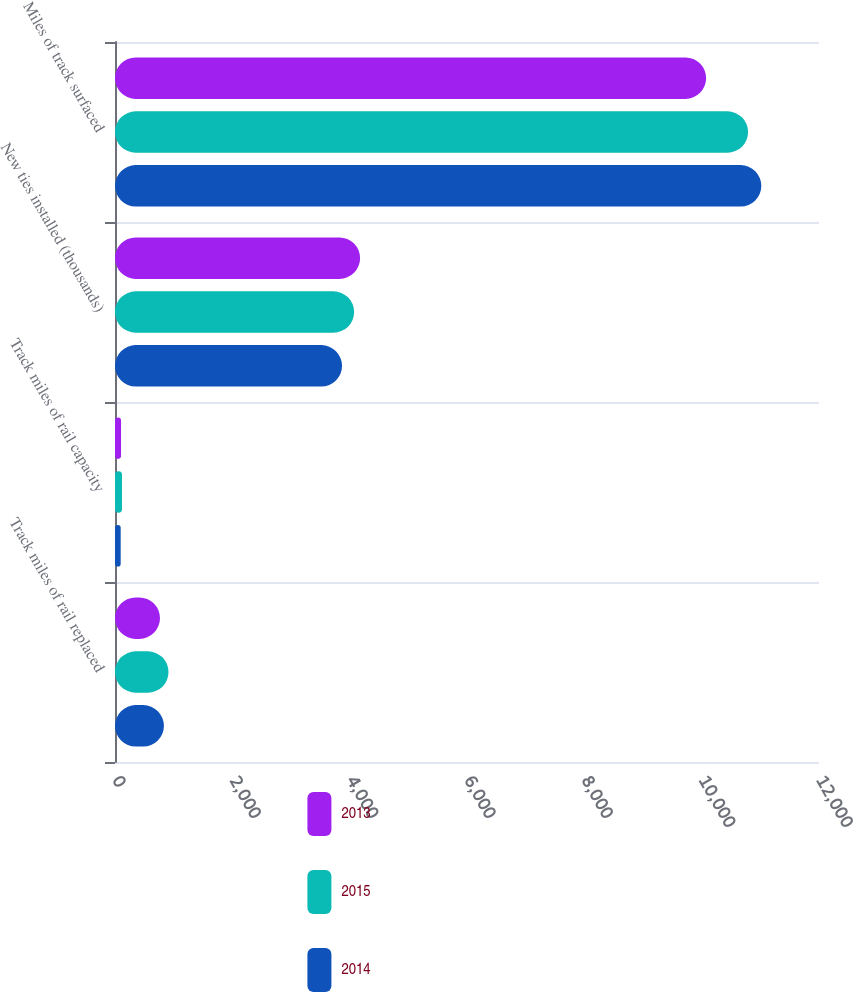Convert chart to OTSL. <chart><loc_0><loc_0><loc_500><loc_500><stacked_bar_chart><ecel><fcel>Track miles of rail replaced<fcel>Track miles of rail capacity<fcel>New ties installed (thousands)<fcel>Miles of track surfaced<nl><fcel>2013<fcel>767<fcel>103<fcel>4178<fcel>10076<nl><fcel>2015<fcel>912<fcel>119<fcel>4076<fcel>10791<nl><fcel>2014<fcel>834<fcel>97<fcel>3870<fcel>11017<nl></chart> 